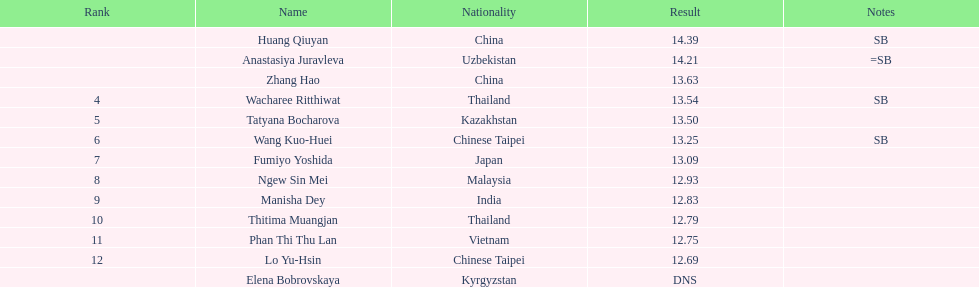How long was manisha dey's jump? 12.83. 